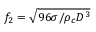Convert formula to latex. <formula><loc_0><loc_0><loc_500><loc_500>f _ { 2 } = \sqrt { 9 6 \sigma / \rho _ { c } D ^ { 3 } }</formula> 